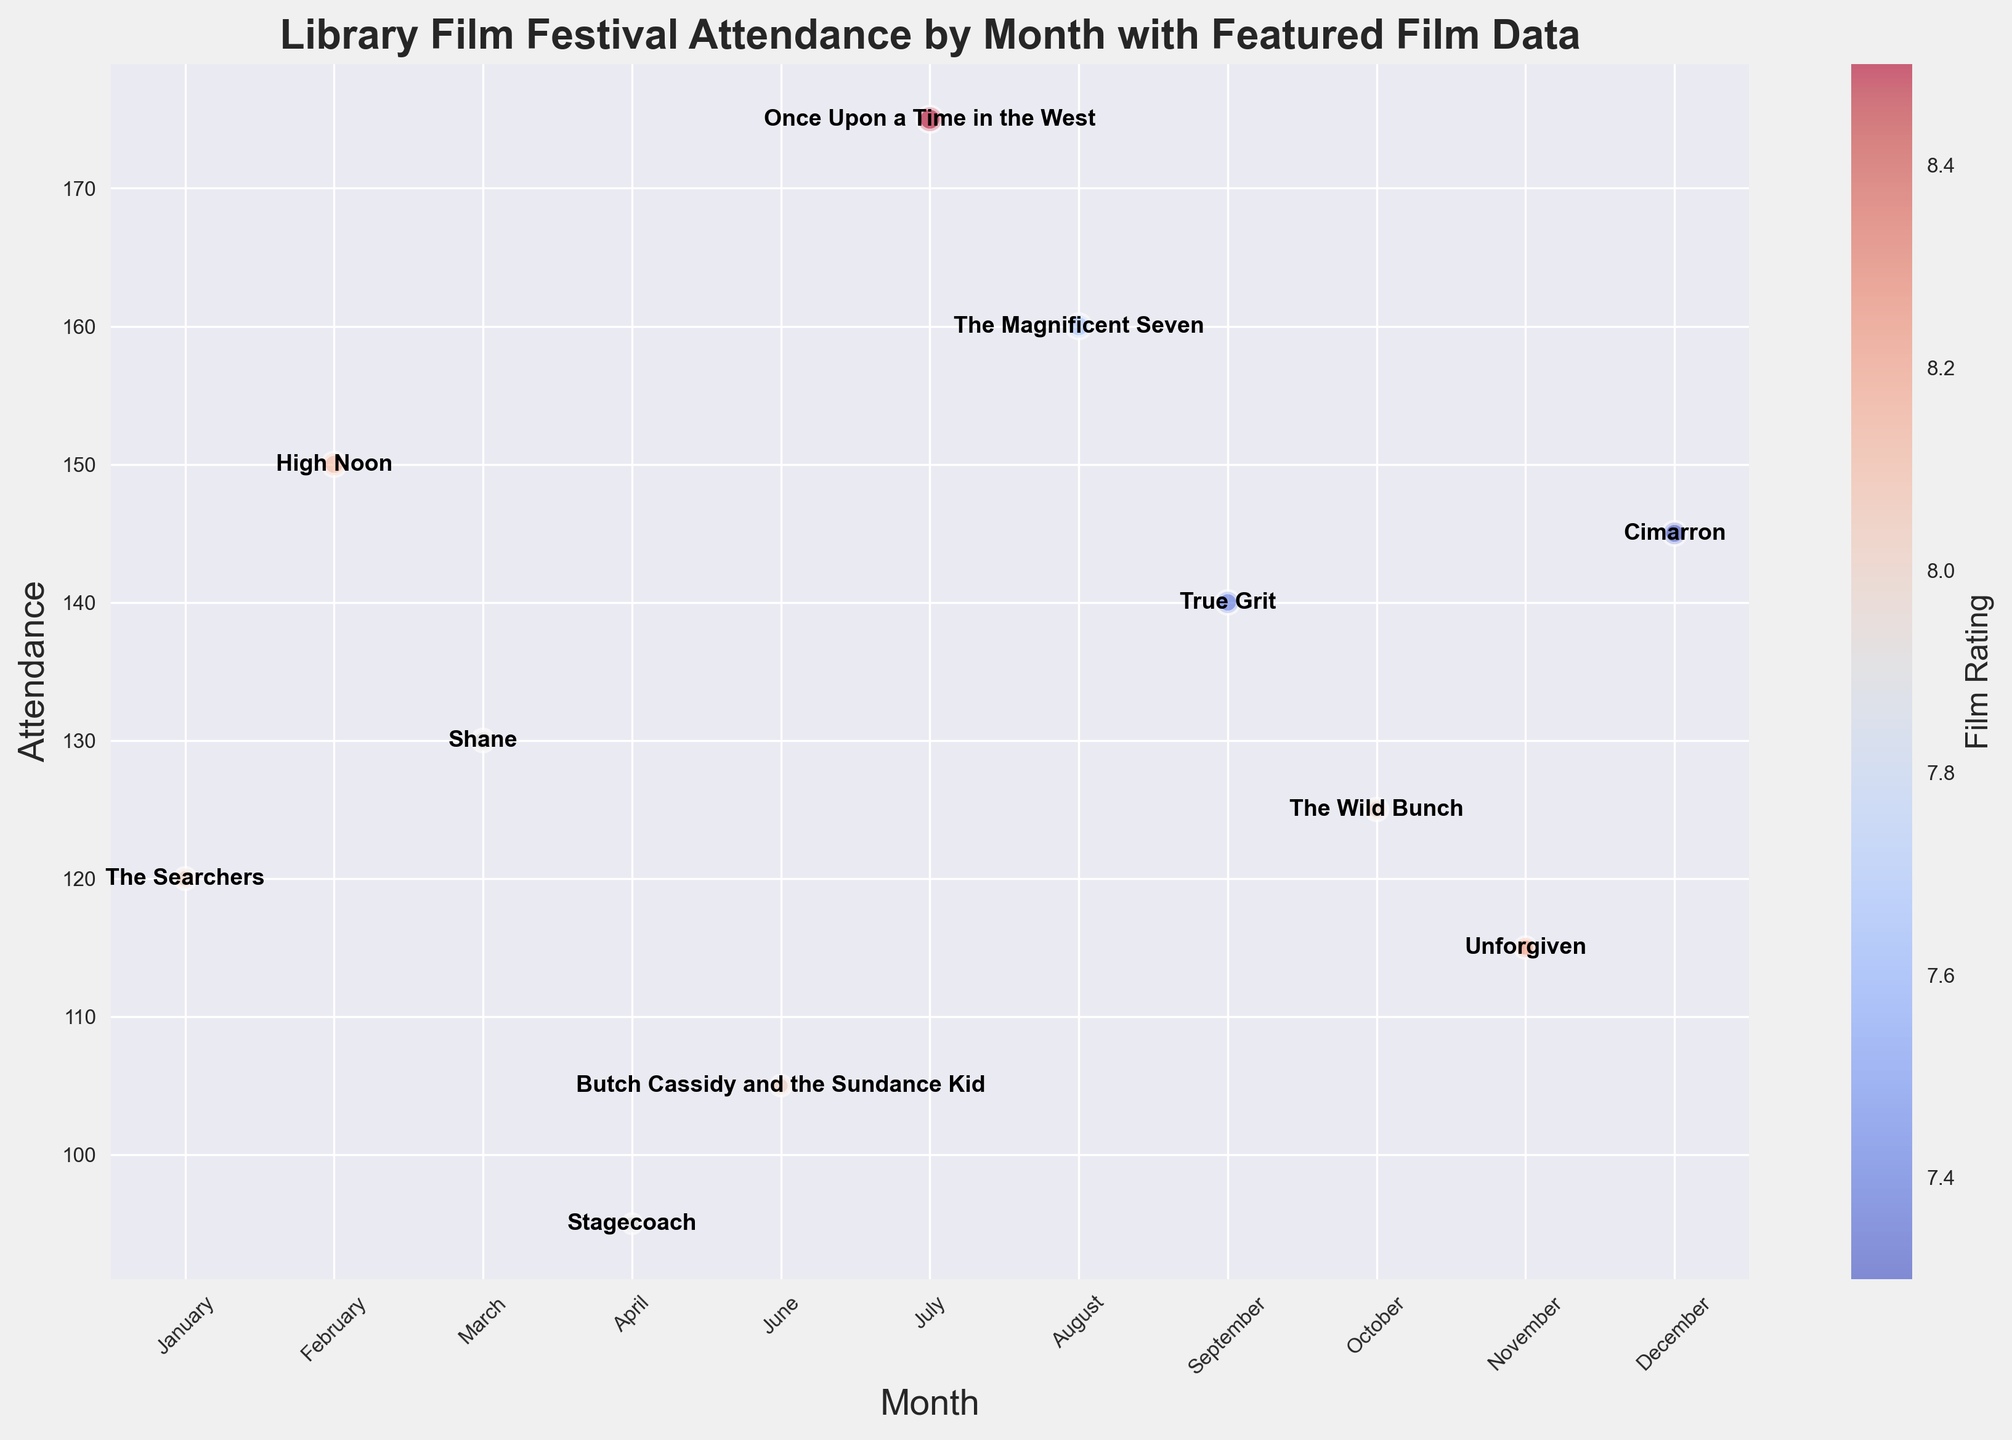What is the highest attendance month, and which film was featured? The highest attendance can be identified by the largest bubble in the scatter plot, and the annotation within the bubble will indicate the featured film. The biggest bubble is in July with 'Once Upon a Time in the West'.
Answer: July, Once Upon a Time in the West Which month had the lowest film rating, and what was the attendance? The lowest film rating can be identified by the darkest (reddish) bubble in the colorbar, and the attendance can be read directly from the y-axis. The darkest bubble is in December with a rating of 7.3, attended by 145 people.
Answer: December, 145 Compare the attendance in January and December. Which month had higher attendance, and what are the attendance figures? Look at the y-axis positions for January and December and compare the heights. January has an attendance of 120, whereas December has an attendance of 145; December has higher attendance.
Answer: December, 145 vs. January, 120 Calculate the average attendance for the months with a film rating of 8.0 or higher. Identify the months where film ratings are 8.0 or higher and sum their attendance, then divide by the number of such months. The months are January (120), February (150), June (105), July (175), October (125), and November (115). Total attendance is 790 from 6 months, so average attendance is 790/6.
Answer: 131.67 Which film had the lowest attendance, and what month was it featured? The smallest bubble on the plot will indicate the lowest attendance, and the annotation within the bubble will show the featured film. The smallest bubble is in April featuring 'Stagecoach' with an attendance of 95.
Answer: Stagecoach, April Is there a correlation between film ratings and attendance? Provide an example to support your answer. Visually inspect the plot for any trend between bubble size (attendance) and color (film rating). July's film 'Once Upon a Time in the West' had the highest attendance (175) and relatively high rating (8.5), showing a potential positive correlation.
Answer: Yes, example: July's film Compare the attendance in February and August. Which month had higher attendance, and by how much? Look at the y-axis positions for February and August and compare the heights. February has 150, and August has 160; August has higher attendance by 10.
Answer: August, by 10 Which month featured the film 'True Grit' and what was its rating? Find the month annotated with 'True Grit' and read its rating from the bubble color or from the legend. 'True Grit' is featured in September with a rating of 7.4.
Answer: September, 7.4 Identify the month with the film 'High Noon' and its respective attendance and film rating. Locate the annotation for 'High Noon', then read the corresponding y-axis (attendance) and color (rating) values from the plot. 'High Noon' is featured in February with an attendance of 150 and a rating of 8.1.
Answer: February, 150, 8.1 